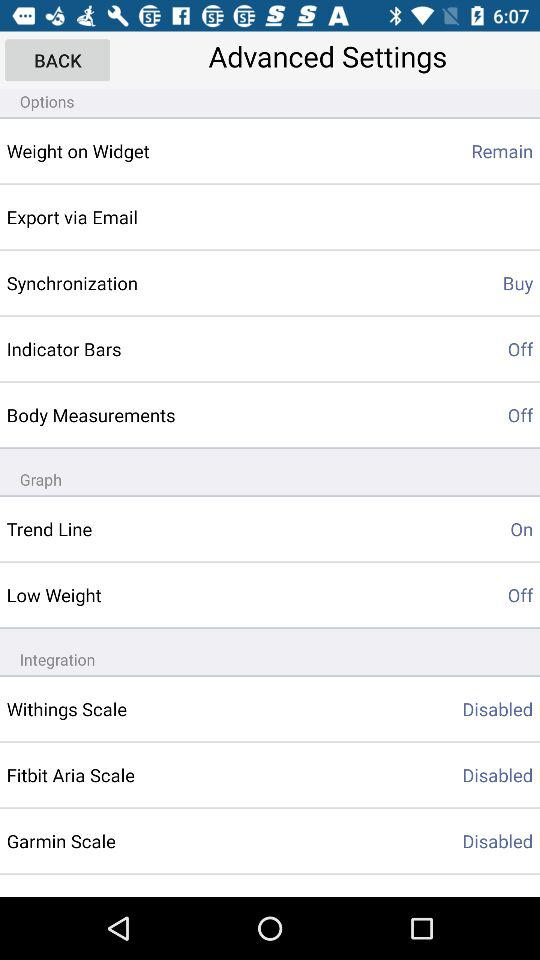What is the status of "Trend Line"? The status of "Trend Line" is "on". 